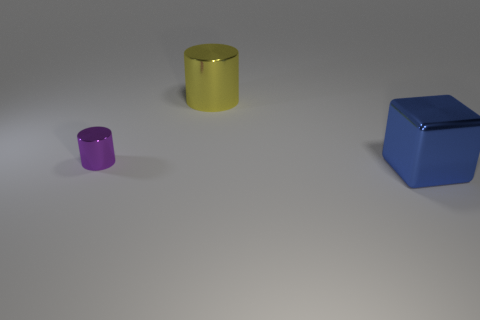Does the large thing that is behind the blue cube have the same color as the big block?
Offer a very short reply. No. What number of yellow things are either small cylinders or metal blocks?
Ensure brevity in your answer.  0. Is there any other thing that is made of the same material as the large yellow cylinder?
Keep it short and to the point. Yes. Do the big thing on the right side of the yellow metal cylinder and the large cylinder have the same material?
Give a very brief answer. Yes. How many things are cyan cubes or big metallic things behind the small cylinder?
Give a very brief answer. 1. There is a shiny cylinder in front of the big metal thing that is behind the tiny metallic object; what number of tiny purple things are on the right side of it?
Offer a terse response. 0. Does the large shiny object that is to the left of the large blue cube have the same shape as the tiny shiny thing?
Offer a terse response. Yes. Are there any large yellow metal objects left of the cylinder right of the small shiny cylinder?
Your answer should be compact. No. How many small yellow balls are there?
Make the answer very short. 0. What color is the shiny thing that is both behind the big metallic cube and right of the tiny purple thing?
Provide a succinct answer. Yellow. 